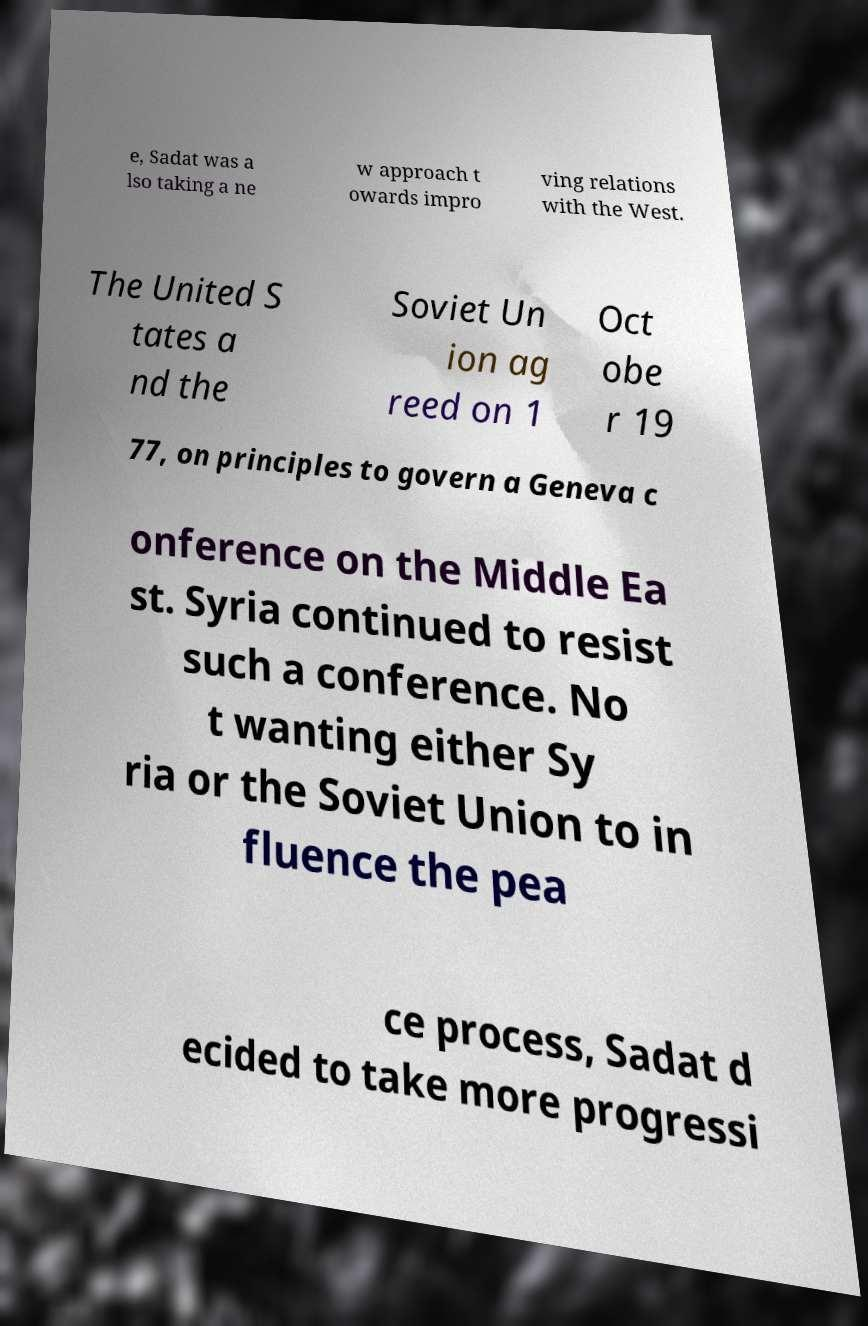I need the written content from this picture converted into text. Can you do that? e, Sadat was a lso taking a ne w approach t owards impro ving relations with the West. The United S tates a nd the Soviet Un ion ag reed on 1 Oct obe r 19 77, on principles to govern a Geneva c onference on the Middle Ea st. Syria continued to resist such a conference. No t wanting either Sy ria or the Soviet Union to in fluence the pea ce process, Sadat d ecided to take more progressi 